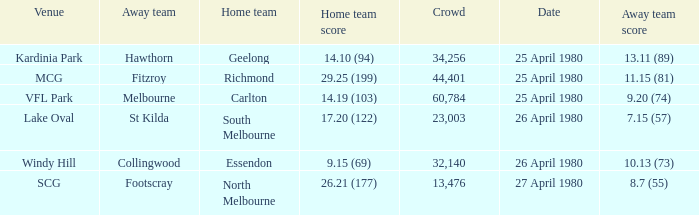What was the lowest crowd size at MCG? 44401.0. I'm looking to parse the entire table for insights. Could you assist me with that? {'header': ['Venue', 'Away team', 'Home team', 'Home team score', 'Crowd', 'Date', 'Away team score'], 'rows': [['Kardinia Park', 'Hawthorn', 'Geelong', '14.10 (94)', '34,256', '25 April 1980', '13.11 (89)'], ['MCG', 'Fitzroy', 'Richmond', '29.25 (199)', '44,401', '25 April 1980', '11.15 (81)'], ['VFL Park', 'Melbourne', 'Carlton', '14.19 (103)', '60,784', '25 April 1980', '9.20 (74)'], ['Lake Oval', 'St Kilda', 'South Melbourne', '17.20 (122)', '23,003', '26 April 1980', '7.15 (57)'], ['Windy Hill', 'Collingwood', 'Essendon', '9.15 (69)', '32,140', '26 April 1980', '10.13 (73)'], ['SCG', 'Footscray', 'North Melbourne', '26.21 (177)', '13,476', '27 April 1980', '8.7 (55)']]} 